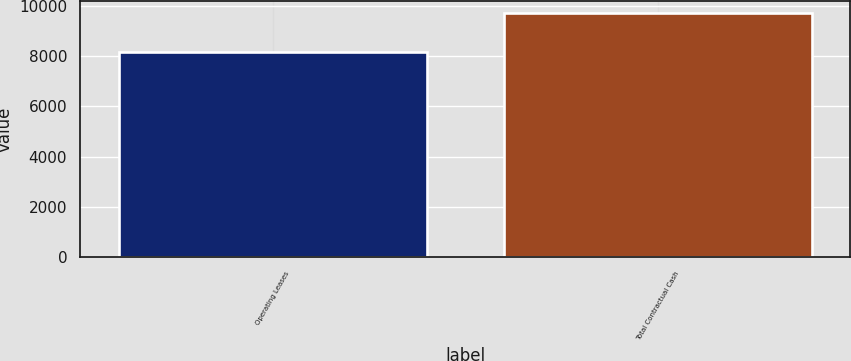Convert chart to OTSL. <chart><loc_0><loc_0><loc_500><loc_500><bar_chart><fcel>Operating Leases<fcel>Total Contractual Cash<nl><fcel>8160<fcel>9710<nl></chart> 